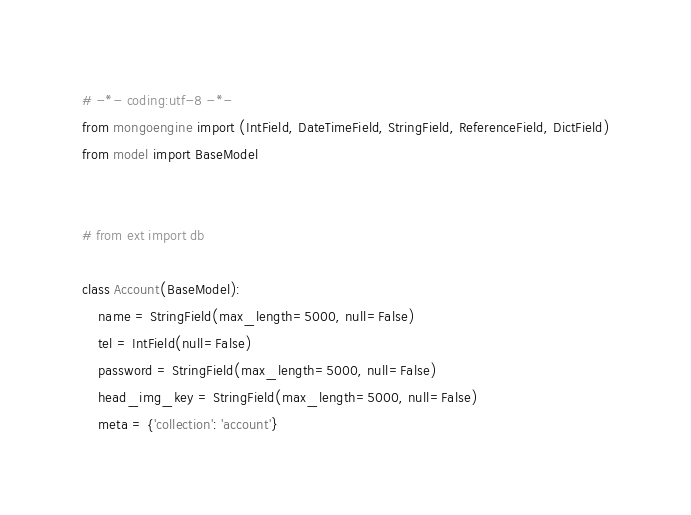<code> <loc_0><loc_0><loc_500><loc_500><_Python_># -*- coding:utf-8 -*-
from mongoengine import (IntField, DateTimeField, StringField, ReferenceField, DictField)
from model import BaseModel


# from ext import db

class Account(BaseModel):
    name = StringField(max_length=5000, null=False)
    tel = IntField(null=False)
    password = StringField(max_length=5000, null=False)
    head_img_key = StringField(max_length=5000, null=False)
    meta = {'collection': 'account'}
</code> 